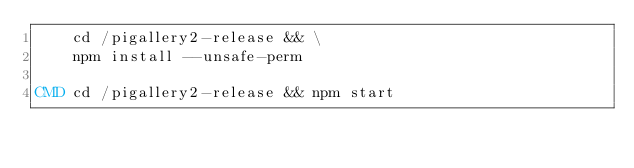<code> <loc_0><loc_0><loc_500><loc_500><_Dockerfile_>    cd /pigallery2-release && \
    npm install --unsafe-perm

CMD cd /pigallery2-release && npm start
</code> 